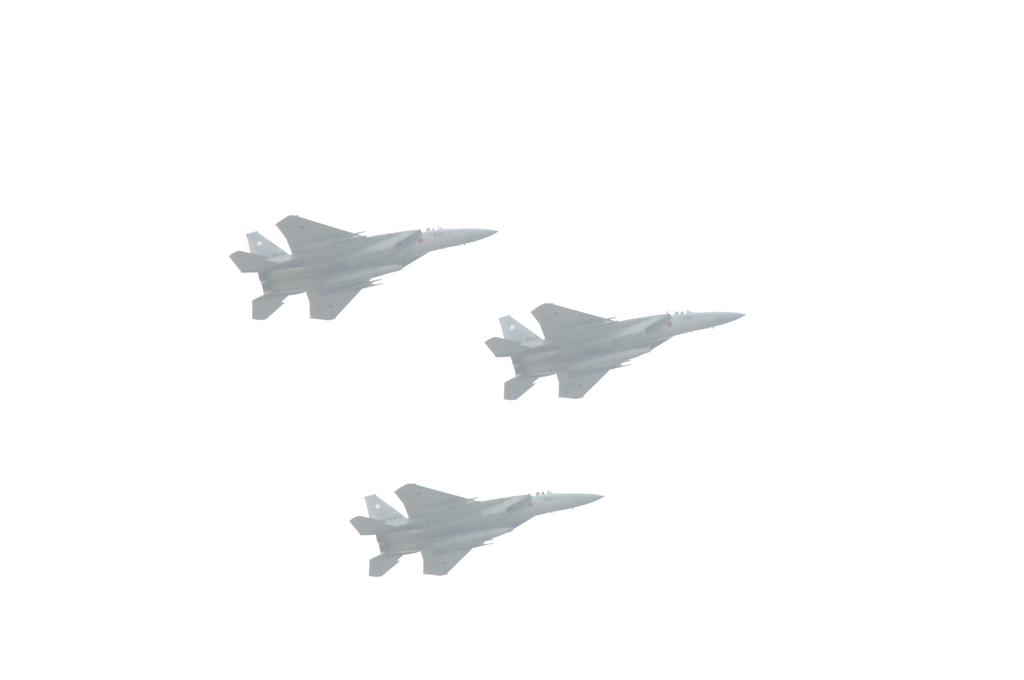What is the main subject of the picture? The main subject of the picture is airplanes. What can be seen in the background of the image? The background of the image is white. How many toes can be seen on the airplanes in the image? There are no toes present in the image, as it features airplanes and not living beings with toes. 